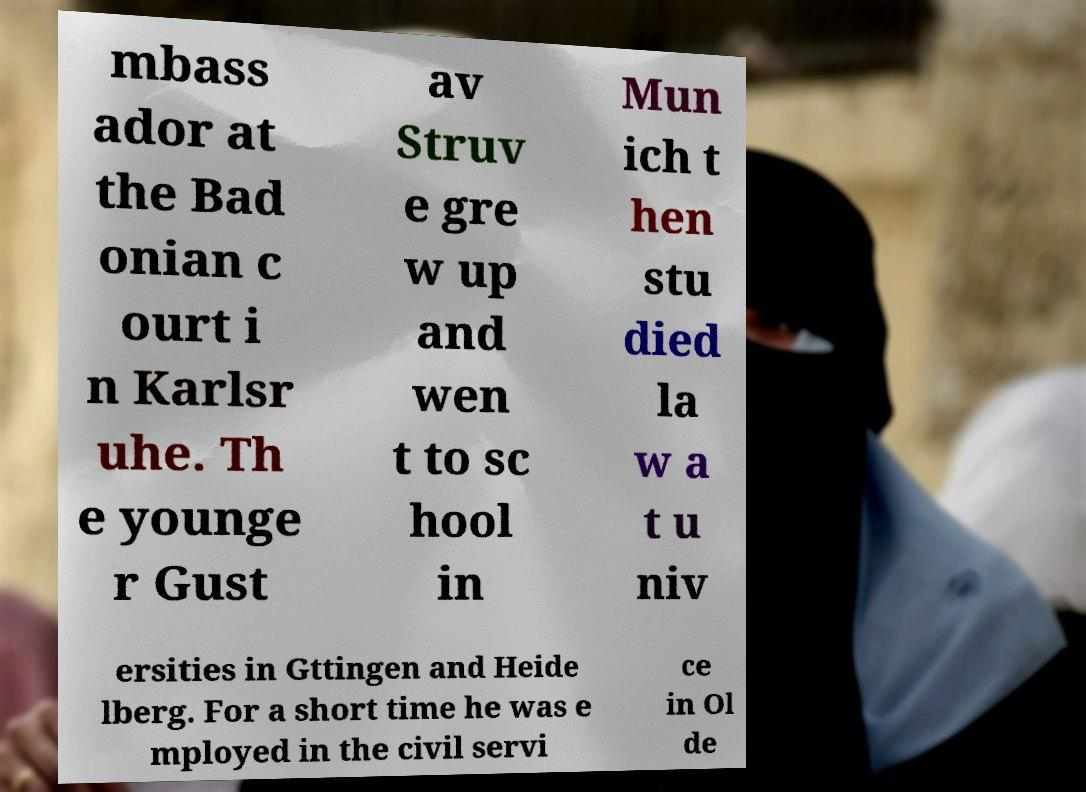Can you read and provide the text displayed in the image?This photo seems to have some interesting text. Can you extract and type it out for me? mbass ador at the Bad onian c ourt i n Karlsr uhe. Th e younge r Gust av Struv e gre w up and wen t to sc hool in Mun ich t hen stu died la w a t u niv ersities in Gttingen and Heide lberg. For a short time he was e mployed in the civil servi ce in Ol de 